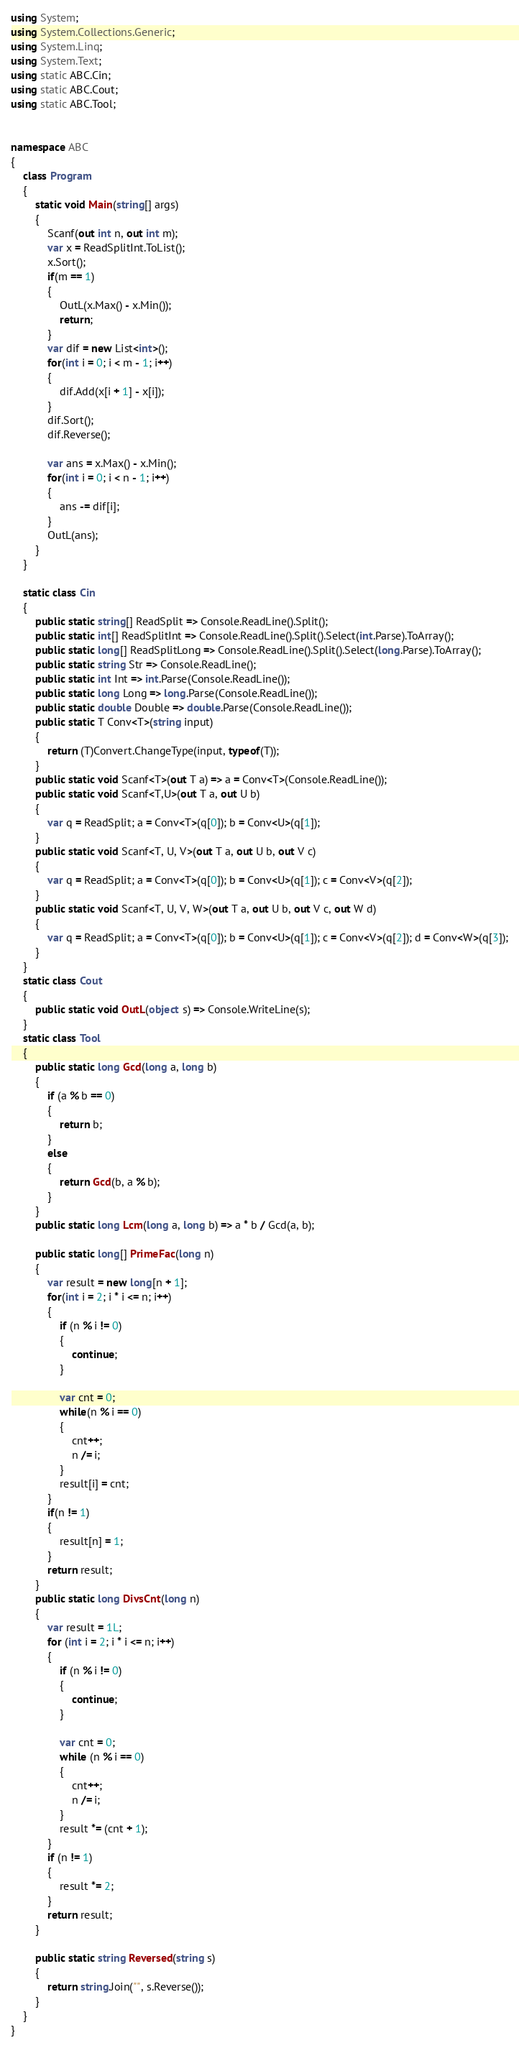<code> <loc_0><loc_0><loc_500><loc_500><_C#_>using System;
using System.Collections.Generic;
using System.Linq;
using System.Text;
using static ABC.Cin;
using static ABC.Cout;
using static ABC.Tool;


namespace ABC
{
    class Program
    {
        static void Main(string[] args)
        {
            Scanf(out int n, out int m);
            var x = ReadSplitInt.ToList();
            x.Sort();
            if(m == 1)
            {
                OutL(x.Max() - x.Min());
                return;
            }
            var dif = new List<int>();
            for(int i = 0; i < m - 1; i++)
            {
                dif.Add(x[i + 1] - x[i]);
            }
            dif.Sort();
            dif.Reverse();

            var ans = x.Max() - x.Min();
            for(int i = 0; i < n - 1; i++)
            {
                ans -= dif[i];
            }
            OutL(ans);
        }
    }

    static class Cin
    {
        public static string[] ReadSplit => Console.ReadLine().Split();
        public static int[] ReadSplitInt => Console.ReadLine().Split().Select(int.Parse).ToArray();
        public static long[] ReadSplitLong => Console.ReadLine().Split().Select(long.Parse).ToArray();
        public static string Str => Console.ReadLine();
        public static int Int => int.Parse(Console.ReadLine());
        public static long Long => long.Parse(Console.ReadLine());
        public static double Double => double.Parse(Console.ReadLine());
        public static T Conv<T>(string input)
        {
            return (T)Convert.ChangeType(input, typeof(T));
        }
        public static void Scanf<T>(out T a) => a = Conv<T>(Console.ReadLine());
        public static void Scanf<T,U>(out T a, out U b)
        {
            var q = ReadSplit; a = Conv<T>(q[0]); b = Conv<U>(q[1]);
        }
        public static void Scanf<T, U, V>(out T a, out U b, out V c)
        {
            var q = ReadSplit; a = Conv<T>(q[0]); b = Conv<U>(q[1]); c = Conv<V>(q[2]);
        }
        public static void Scanf<T, U, V, W>(out T a, out U b, out V c, out W d)
        {
            var q = ReadSplit; a = Conv<T>(q[0]); b = Conv<U>(q[1]); c = Conv<V>(q[2]); d = Conv<W>(q[3]);
        }
    }
    static class Cout
    {
        public static void OutL(object s) => Console.WriteLine(s);
    }
    static class Tool
    {
        public static long Gcd(long a, long b)
        {
            if (a % b == 0)
            {
                return b;
            }
            else
            {
                return Gcd(b, a % b);
            }
        }
        public static long Lcm(long a, long b) => a * b / Gcd(a, b);

        public static long[] PrimeFac(long n)
        {
            var result = new long[n + 1];
            for(int i = 2; i * i <= n; i++)
            {
                if (n % i != 0)
                {
                    continue;
                }

                var cnt = 0;
                while(n % i == 0)
                {
                    cnt++;
                    n /= i;
                }
                result[i] = cnt;
            }
            if(n != 1)
            {
                result[n] = 1;
            }
            return result;
        }
        public static long DivsCnt(long n)
        {
            var result = 1L;
            for (int i = 2; i * i <= n; i++)
            {
                if (n % i != 0)
                {
                    continue;
                }

                var cnt = 0;
                while (n % i == 0)
                {
                    cnt++;
                    n /= i;
                }
                result *= (cnt + 1);
            }
            if (n != 1)
            {
                result *= 2;
            }
            return result;
        }

        public static string Reversed(string s)
        {
            return string.Join("", s.Reverse());
        }
    }
}</code> 